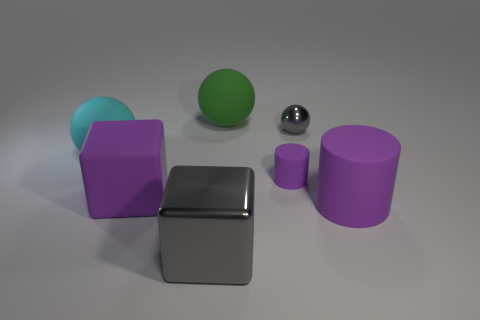Does the gray metal thing behind the cyan rubber thing have the same shape as the green rubber thing?
Provide a succinct answer. Yes. What is the color of the large metallic cube?
Keep it short and to the point. Gray. There is a large rubber object that is the same shape as the big shiny object; what is its color?
Provide a succinct answer. Purple. How many big blue shiny objects are the same shape as the cyan matte thing?
Your response must be concise. 0. How many objects are either green objects or purple things that are in front of the rubber block?
Your answer should be compact. 2. There is a large rubber cylinder; is its color the same as the tiny object in front of the tiny gray sphere?
Offer a terse response. Yes. What is the size of the matte thing that is both in front of the tiny purple matte cylinder and on the left side of the tiny gray metallic ball?
Provide a short and direct response. Large. There is a big green rubber object; are there any balls to the left of it?
Offer a very short reply. Yes. Is there a gray shiny object to the left of the gray shiny object that is in front of the big cylinder?
Your answer should be compact. No. Are there the same number of cylinders that are behind the big purple rubber block and big green things that are to the left of the cyan sphere?
Ensure brevity in your answer.  No. 